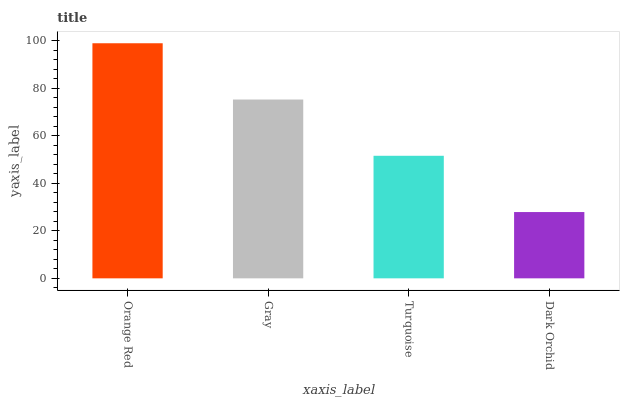Is Dark Orchid the minimum?
Answer yes or no. Yes. Is Orange Red the maximum?
Answer yes or no. Yes. Is Gray the minimum?
Answer yes or no. No. Is Gray the maximum?
Answer yes or no. No. Is Orange Red greater than Gray?
Answer yes or no. Yes. Is Gray less than Orange Red?
Answer yes or no. Yes. Is Gray greater than Orange Red?
Answer yes or no. No. Is Orange Red less than Gray?
Answer yes or no. No. Is Gray the high median?
Answer yes or no. Yes. Is Turquoise the low median?
Answer yes or no. Yes. Is Dark Orchid the high median?
Answer yes or no. No. Is Dark Orchid the low median?
Answer yes or no. No. 